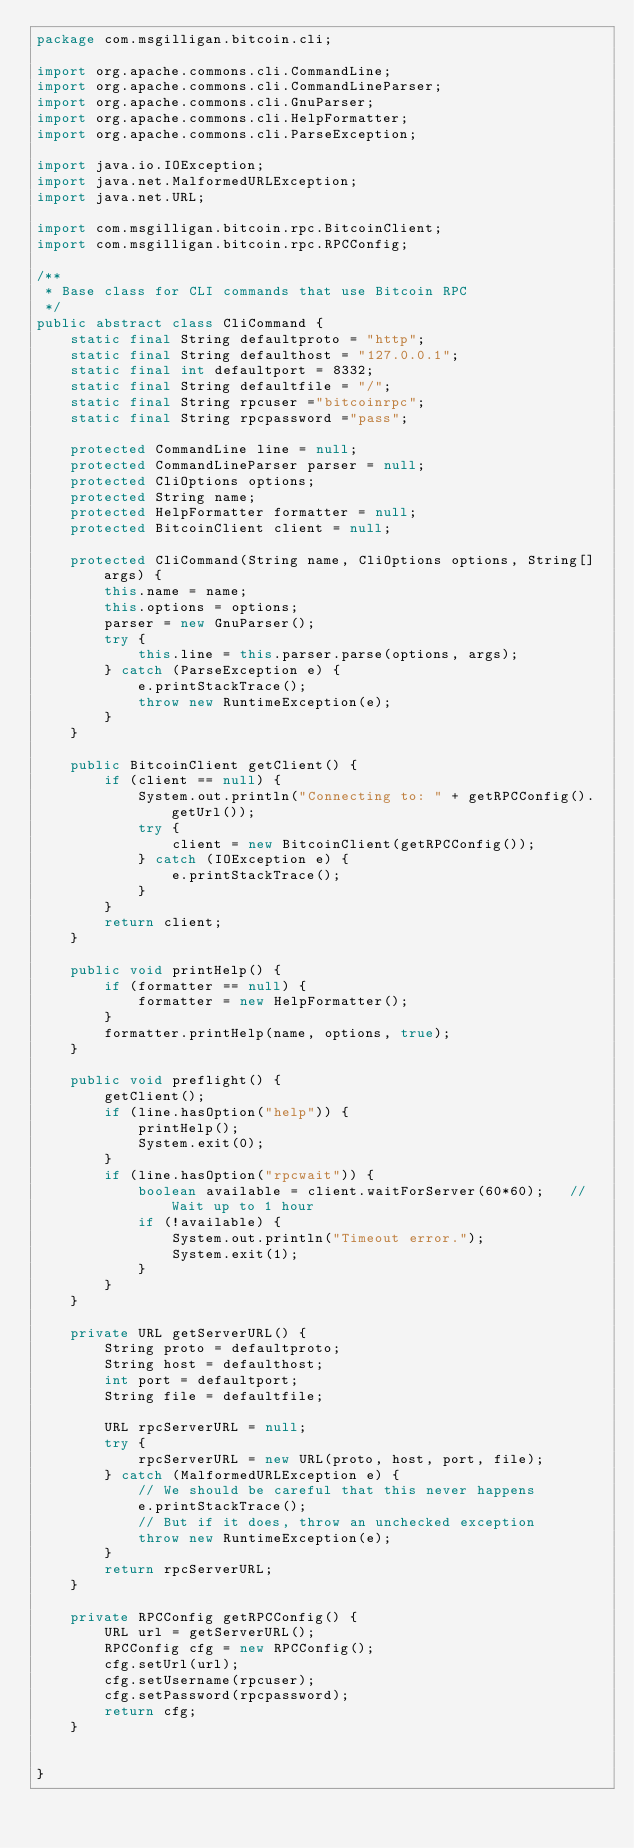<code> <loc_0><loc_0><loc_500><loc_500><_Java_>package com.msgilligan.bitcoin.cli;

import org.apache.commons.cli.CommandLine;
import org.apache.commons.cli.CommandLineParser;
import org.apache.commons.cli.GnuParser;
import org.apache.commons.cli.HelpFormatter;
import org.apache.commons.cli.ParseException;

import java.io.IOException;
import java.net.MalformedURLException;
import java.net.URL;

import com.msgilligan.bitcoin.rpc.BitcoinClient;
import com.msgilligan.bitcoin.rpc.RPCConfig;

/**
 * Base class for CLI commands that use Bitcoin RPC
 */
public abstract class CliCommand {
    static final String defaultproto = "http";
    static final String defaulthost = "127.0.0.1";
    static final int defaultport = 8332;
    static final String defaultfile = "/";
    static final String rpcuser ="bitcoinrpc";
    static final String rpcpassword ="pass";

    protected CommandLine line = null;
    protected CommandLineParser parser = null;
    protected CliOptions options;
    protected String name;
    protected HelpFormatter formatter = null;
    protected BitcoinClient client = null;

    protected CliCommand(String name, CliOptions options, String[] args) {
        this.name = name;
        this.options = options;
        parser = new GnuParser();
        try {
            this.line = this.parser.parse(options, args);
        } catch (ParseException e) {
            e.printStackTrace();
            throw new RuntimeException(e);
        }
    }

    public BitcoinClient getClient() {
        if (client == null) {
            System.out.println("Connecting to: " + getRPCConfig().getUrl());
            try {
                client = new BitcoinClient(getRPCConfig());
            } catch (IOException e) {
                e.printStackTrace();
            }
        }
        return client;
    }

    public void printHelp() {
        if (formatter == null) {
            formatter = new HelpFormatter();
        }
        formatter.printHelp(name, options, true);
    }

    public void preflight() {
        getClient();
        if (line.hasOption("help")) {
            printHelp();
            System.exit(0);
        }
        if (line.hasOption("rpcwait")) {
            boolean available = client.waitForServer(60*60);   // Wait up to 1 hour
            if (!available) {
                System.out.println("Timeout error.");
                System.exit(1);
            }
        }
    }

    private URL getServerURL() {
        String proto = defaultproto;
        String host = defaulthost;
        int port = defaultport;
        String file = defaultfile;

        URL rpcServerURL = null;
        try {
            rpcServerURL = new URL(proto, host, port, file);
        } catch (MalformedURLException e) {
            // We should be careful that this never happens
            e.printStackTrace();
            // But if it does, throw an unchecked exception
            throw new RuntimeException(e);
        }
        return rpcServerURL;
    }

    private RPCConfig getRPCConfig() {
        URL url = getServerURL();
        RPCConfig cfg = new RPCConfig();
        cfg.setUrl(url);
        cfg.setUsername(rpcuser);
        cfg.setPassword(rpcpassword);
        return cfg;
    }


}
</code> 